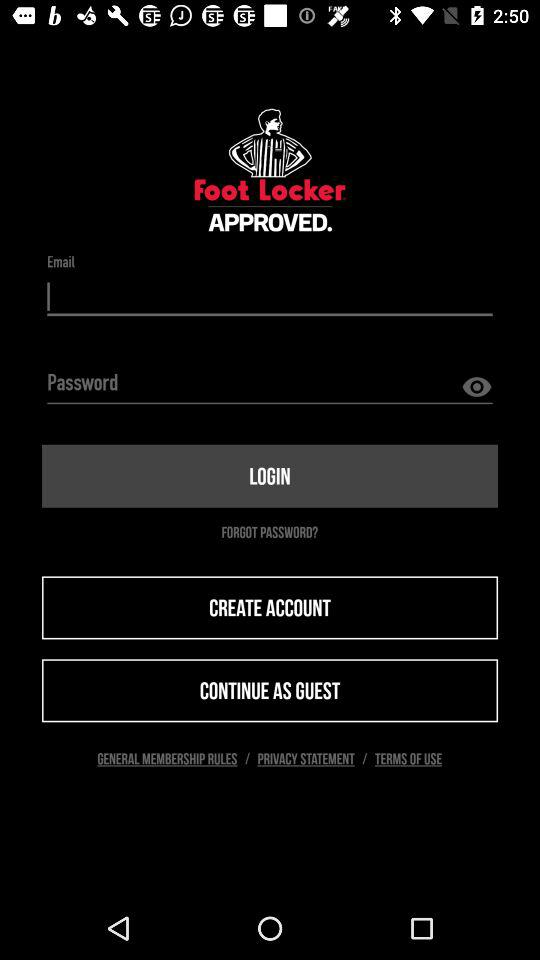What is the name of the application? The name of the application is "Foot Locker". 